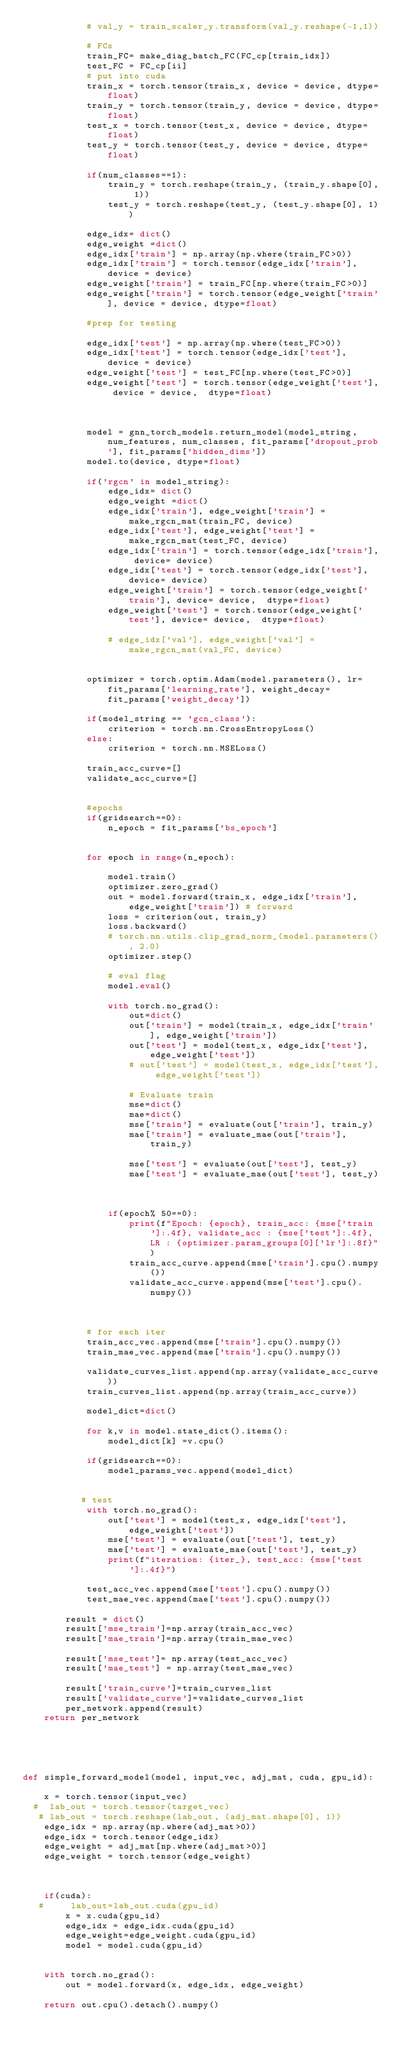Convert code to text. <code><loc_0><loc_0><loc_500><loc_500><_Python_>            # val_y = train_scaler_y.transform(val_y.reshape(-1,1))
            
            # FCs
            train_FC= make_diag_batch_FC(FC_cp[train_idx])
            test_FC = FC_cp[ii]
            # put into cuda 
            train_x = torch.tensor(train_x, device = device, dtype=float)
            train_y = torch.tensor(train_y, device = device, dtype=float)
            test_x = torch.tensor(test_x, device = device, dtype=float)
            test_y = torch.tensor(test_y, device = device, dtype=float)
            
            if(num_classes==1):
                train_y = torch.reshape(train_y, (train_y.shape[0], 1))
                test_y = torch.reshape(test_y, (test_y.shape[0], 1))
                
            edge_idx= dict()
            edge_weight =dict()
            edge_idx['train'] = np.array(np.where(train_FC>0))
            edge_idx['train'] = torch.tensor(edge_idx['train'], device = device)
            edge_weight['train'] = train_FC[np.where(train_FC>0)]
            edge_weight['train'] = torch.tensor(edge_weight['train'], device = device, dtype=float)
                        
            #prep for testing 
           
            edge_idx['test'] = np.array(np.where(test_FC>0))
            edge_idx['test'] = torch.tensor(edge_idx['test'], device = device)
            edge_weight['test'] = test_FC[np.where(test_FC>0)]
            edge_weight['test'] = torch.tensor(edge_weight['test'], device = device,  dtype=float)
            
            
            
            model = gnn_torch_models.return_model(model_string, num_features, num_classes, fit_params['dropout_prob'], fit_params['hidden_dims'])
            model.to(device, dtype=float)            
            
            if('rgcn' in model_string):
                edge_idx= dict()
                edge_weight =dict()
                edge_idx['train'], edge_weight['train'] = make_rgcn_mat(train_FC, device)
                edge_idx['test'], edge_weight['test'] = make_rgcn_mat(test_FC, device)
                edge_idx['train'] = torch.tensor(edge_idx['train'], device= device)
                edge_idx['test'] = torch.tensor(edge_idx['test'], device= device)
                edge_weight['train'] = torch.tensor(edge_weight['train'], device= device,  dtype=float)
                edge_weight['test'] = torch.tensor(edge_weight['test'], device= device,  dtype=float)
                
                # edge_idx['val'], edge_weight['val'] = make_rgcn_mat(val_FC, device)
                
            
            optimizer = torch.optim.Adam(model.parameters(), lr=fit_params['learning_rate'], weight_decay= fit_params['weight_decay'])
          
            if(model_string == 'gcn_class'):
                criterion = torch.nn.CrossEntropyLoss()
            else:
                criterion = torch.nn.MSELoss()
               
            train_acc_curve=[]
            validate_acc_curve=[]
            
            
            #epochs
            if(gridsearch==0):
                n_epoch = fit_params['bs_epoch']
                
            
            for epoch in range(n_epoch):
                
                model.train()
                optimizer.zero_grad()
                out = model.forward(train_x, edge_idx['train'], edge_weight['train']) # forward
                loss = criterion(out, train_y)
                loss.backward()
                # torch.nn.utils.clip_grad_norm_(model.parameters(), 2.0)
                optimizer.step()
                
                # eval flag
                model.eval()
                
                with torch.no_grad():
                    out=dict()
                    out['train'] = model(train_x, edge_idx['train'], edge_weight['train'])
                    out['test'] = model(test_x, edge_idx['test'], edge_weight['test'])
                    # out['test'] = model(test_x, edge_idx['test'], edge_weight['test'])
                    
                    # Evaluate train
                    mse=dict()
                    mae=dict()
                    mse['train'] = evaluate(out['train'], train_y)
                    mae['train'] = evaluate_mae(out['train'], train_y)
                    
                    mse['test'] = evaluate(out['test'], test_y)
                    mae['test'] = evaluate_mae(out['test'], test_y)
                    
                
                
                if(epoch% 50==0):
                    print(f"Epoch: {epoch}, train_acc: {mse['train']:.4f}, validate_acc : {mse['test']:.4f}, LR : {optimizer.param_groups[0]['lr']:.8f}")
                    train_acc_curve.append(mse['train'].cpu().numpy())
                    validate_acc_curve.append(mse['test'].cpu().numpy())
                          
            
                        
            # for each iter
            train_acc_vec.append(mse['train'].cpu().numpy())
            train_mae_vec.append(mae['train'].cpu().numpy())
           
            validate_curves_list.append(np.array(validate_acc_curve))
            train_curves_list.append(np.array(train_acc_curve))
            
            model_dict=dict()
            
            for k,v in model.state_dict().items():
                model_dict[k] =v.cpu()
            
            if(gridsearch==0):
                model_params_vec.append(model_dict)
            
            
           # test
            with torch.no_grad():
                out['test'] = model(test_x, edge_idx['test'], edge_weight['test'])
                mse['test'] = evaluate(out['test'], test_y)
                mae['test'] = evaluate_mae(out['test'], test_y)
                print(f"iteration: {iter_}, test_acc: {mse['test']:.4f}")
            
            test_acc_vec.append(mse['test'].cpu().numpy())
            test_mae_vec.append(mae['test'].cpu().numpy())
         
        result = dict()
        result['mse_train']=np.array(train_acc_vec)
        result['mae_train']=np.array(train_mae_vec)
        
        result['mse_test']= np.array(test_acc_vec)
        result['mae_test'] = np.array(test_mae_vec)
       
        result['train_curve']=train_curves_list
        result['validate_curve']=validate_curves_list
        per_network.append(result)
    return per_network





def simple_forward_model(model, input_vec, adj_mat, cuda, gpu_id):
    
    x = torch.tensor(input_vec)
  #  lab_out = torch.tensor(target_vec)
   # lab_out = torch.reshape(lab_out, (adj_mat.shape[0], 1))
    edge_idx = np.array(np.where(adj_mat>0))
    edge_idx = torch.tensor(edge_idx)
    edge_weight = adj_mat[np.where(adj_mat>0)]
    edge_weight = torch.tensor(edge_weight)
    
    
    
    if(cuda):
   #     lab_out=lab_out.cuda(gpu_id)
        x = x.cuda(gpu_id)
        edge_idx = edge_idx.cuda(gpu_id)
        edge_weight=edge_weight.cuda(gpu_id)
        model = model.cuda(gpu_id)
    
    
    with torch.no_grad():
        out = model.forward(x, edge_idx, edge_weight)
    
    return out.cpu().detach().numpy()

</code> 